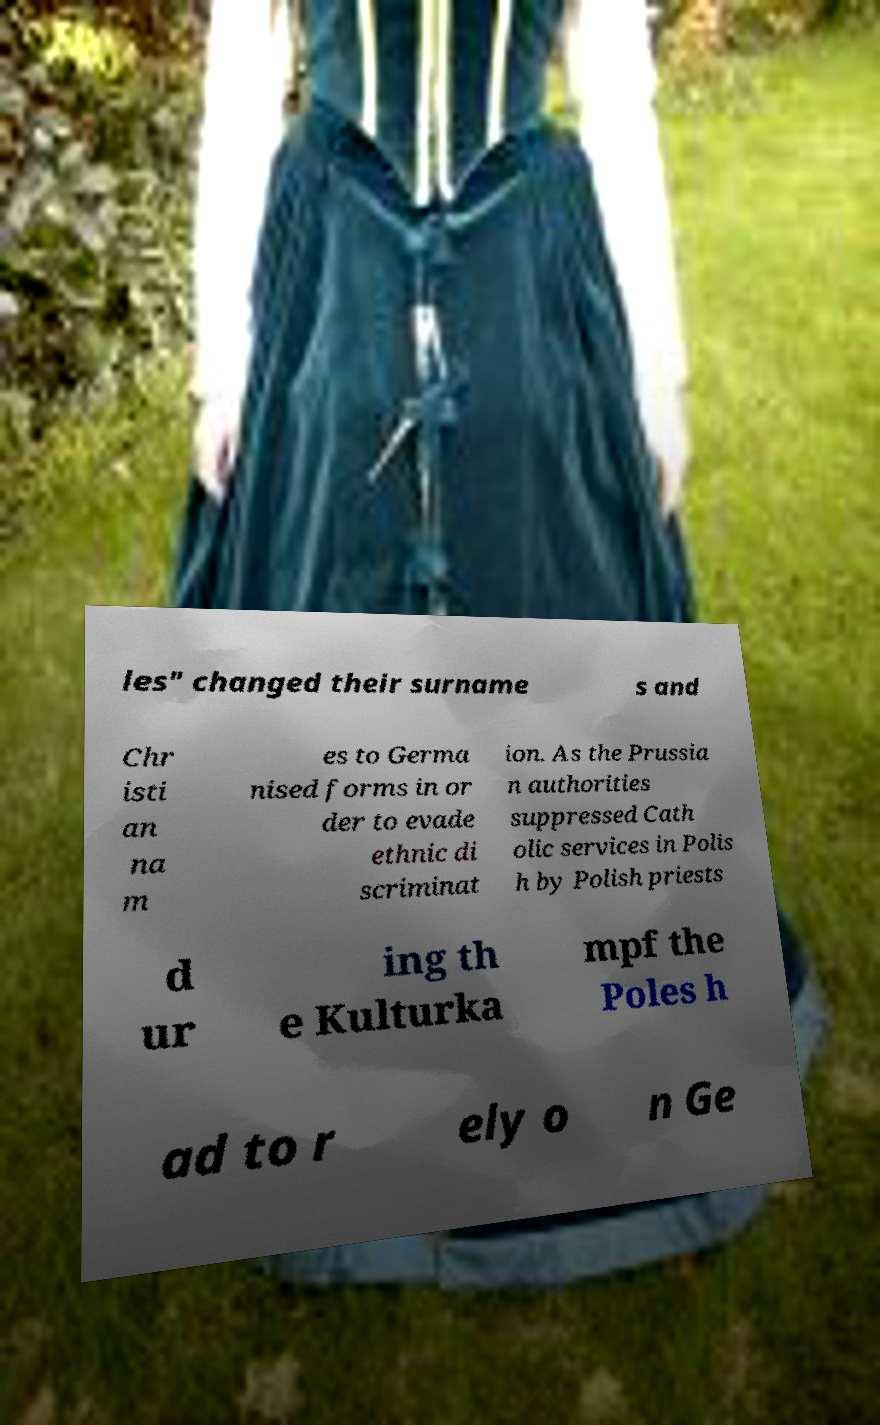Can you accurately transcribe the text from the provided image for me? les" changed their surname s and Chr isti an na m es to Germa nised forms in or der to evade ethnic di scriminat ion. As the Prussia n authorities suppressed Cath olic services in Polis h by Polish priests d ur ing th e Kulturka mpf the Poles h ad to r ely o n Ge 